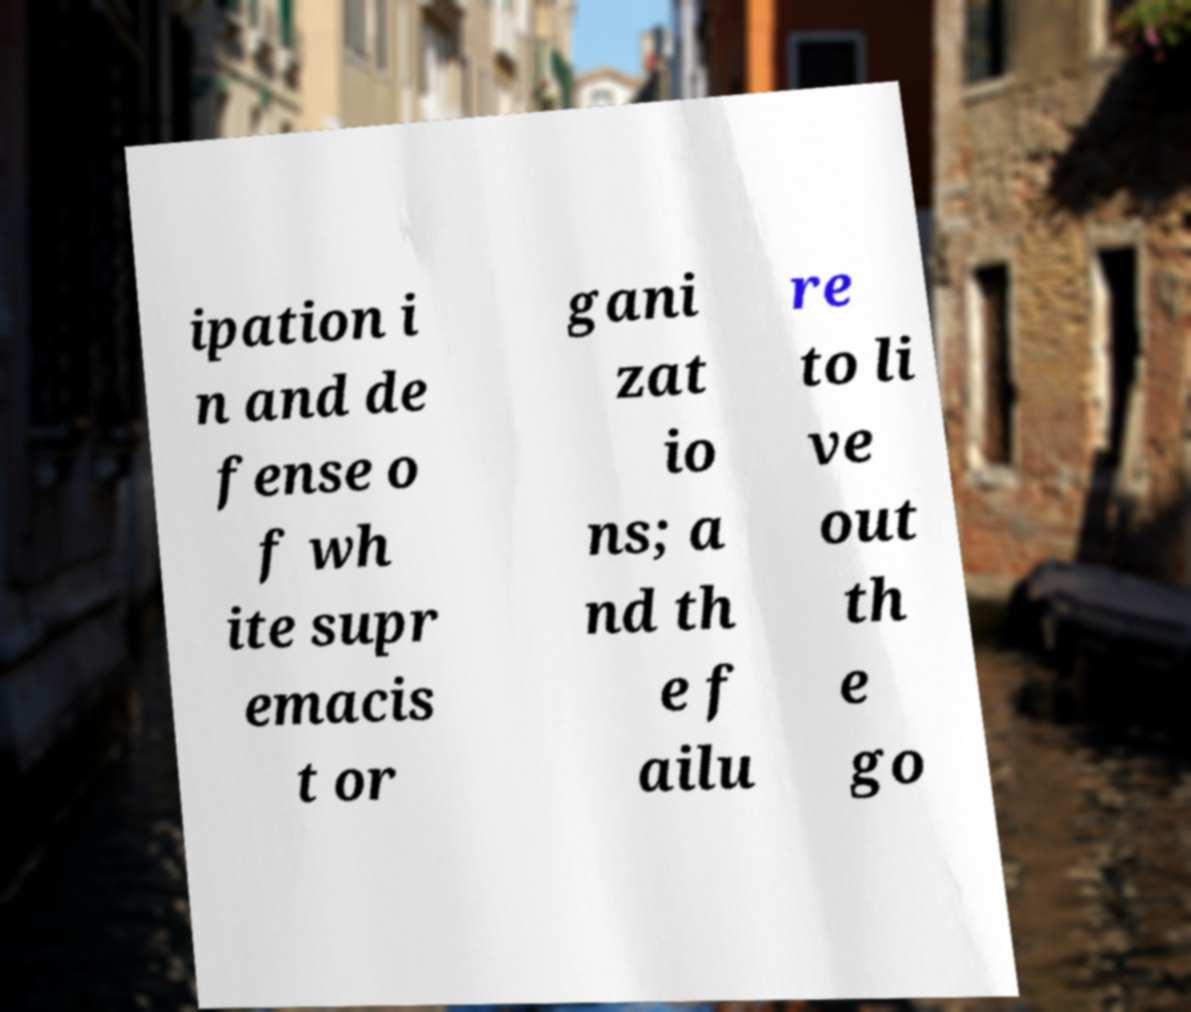Can you accurately transcribe the text from the provided image for me? ipation i n and de fense o f wh ite supr emacis t or gani zat io ns; a nd th e f ailu re to li ve out th e go 